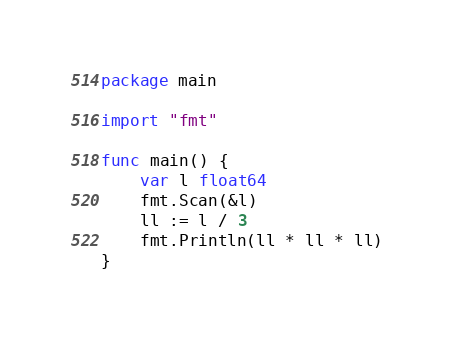Convert code to text. <code><loc_0><loc_0><loc_500><loc_500><_Go_>package main

import "fmt"

func main() {
	var l float64
	fmt.Scan(&l)
	ll := l / 3
	fmt.Println(ll * ll * ll)
}
</code> 